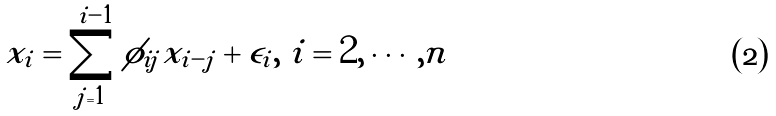Convert formula to latex. <formula><loc_0><loc_0><loc_500><loc_500>x _ { i } = \sum _ { j = 1 } ^ { i - 1 } \phi _ { i j } x _ { i - j } + \epsilon _ { i } , \ i = 2 , \cdots , n</formula> 